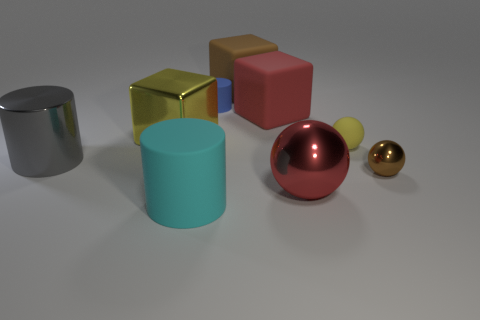Subtract all matte cubes. How many cubes are left? 1 Add 1 large metal cylinders. How many objects exist? 10 Subtract all yellow cubes. How many cubes are left? 2 Subtract 1 balls. How many balls are left? 2 Add 7 big gray metal cylinders. How many big gray metal cylinders are left? 8 Add 5 cylinders. How many cylinders exist? 8 Subtract 1 brown blocks. How many objects are left? 8 Subtract all balls. How many objects are left? 6 Subtract all gray spheres. Subtract all purple cylinders. How many spheres are left? 3 Subtract all big cyan metallic cylinders. Subtract all small yellow balls. How many objects are left? 8 